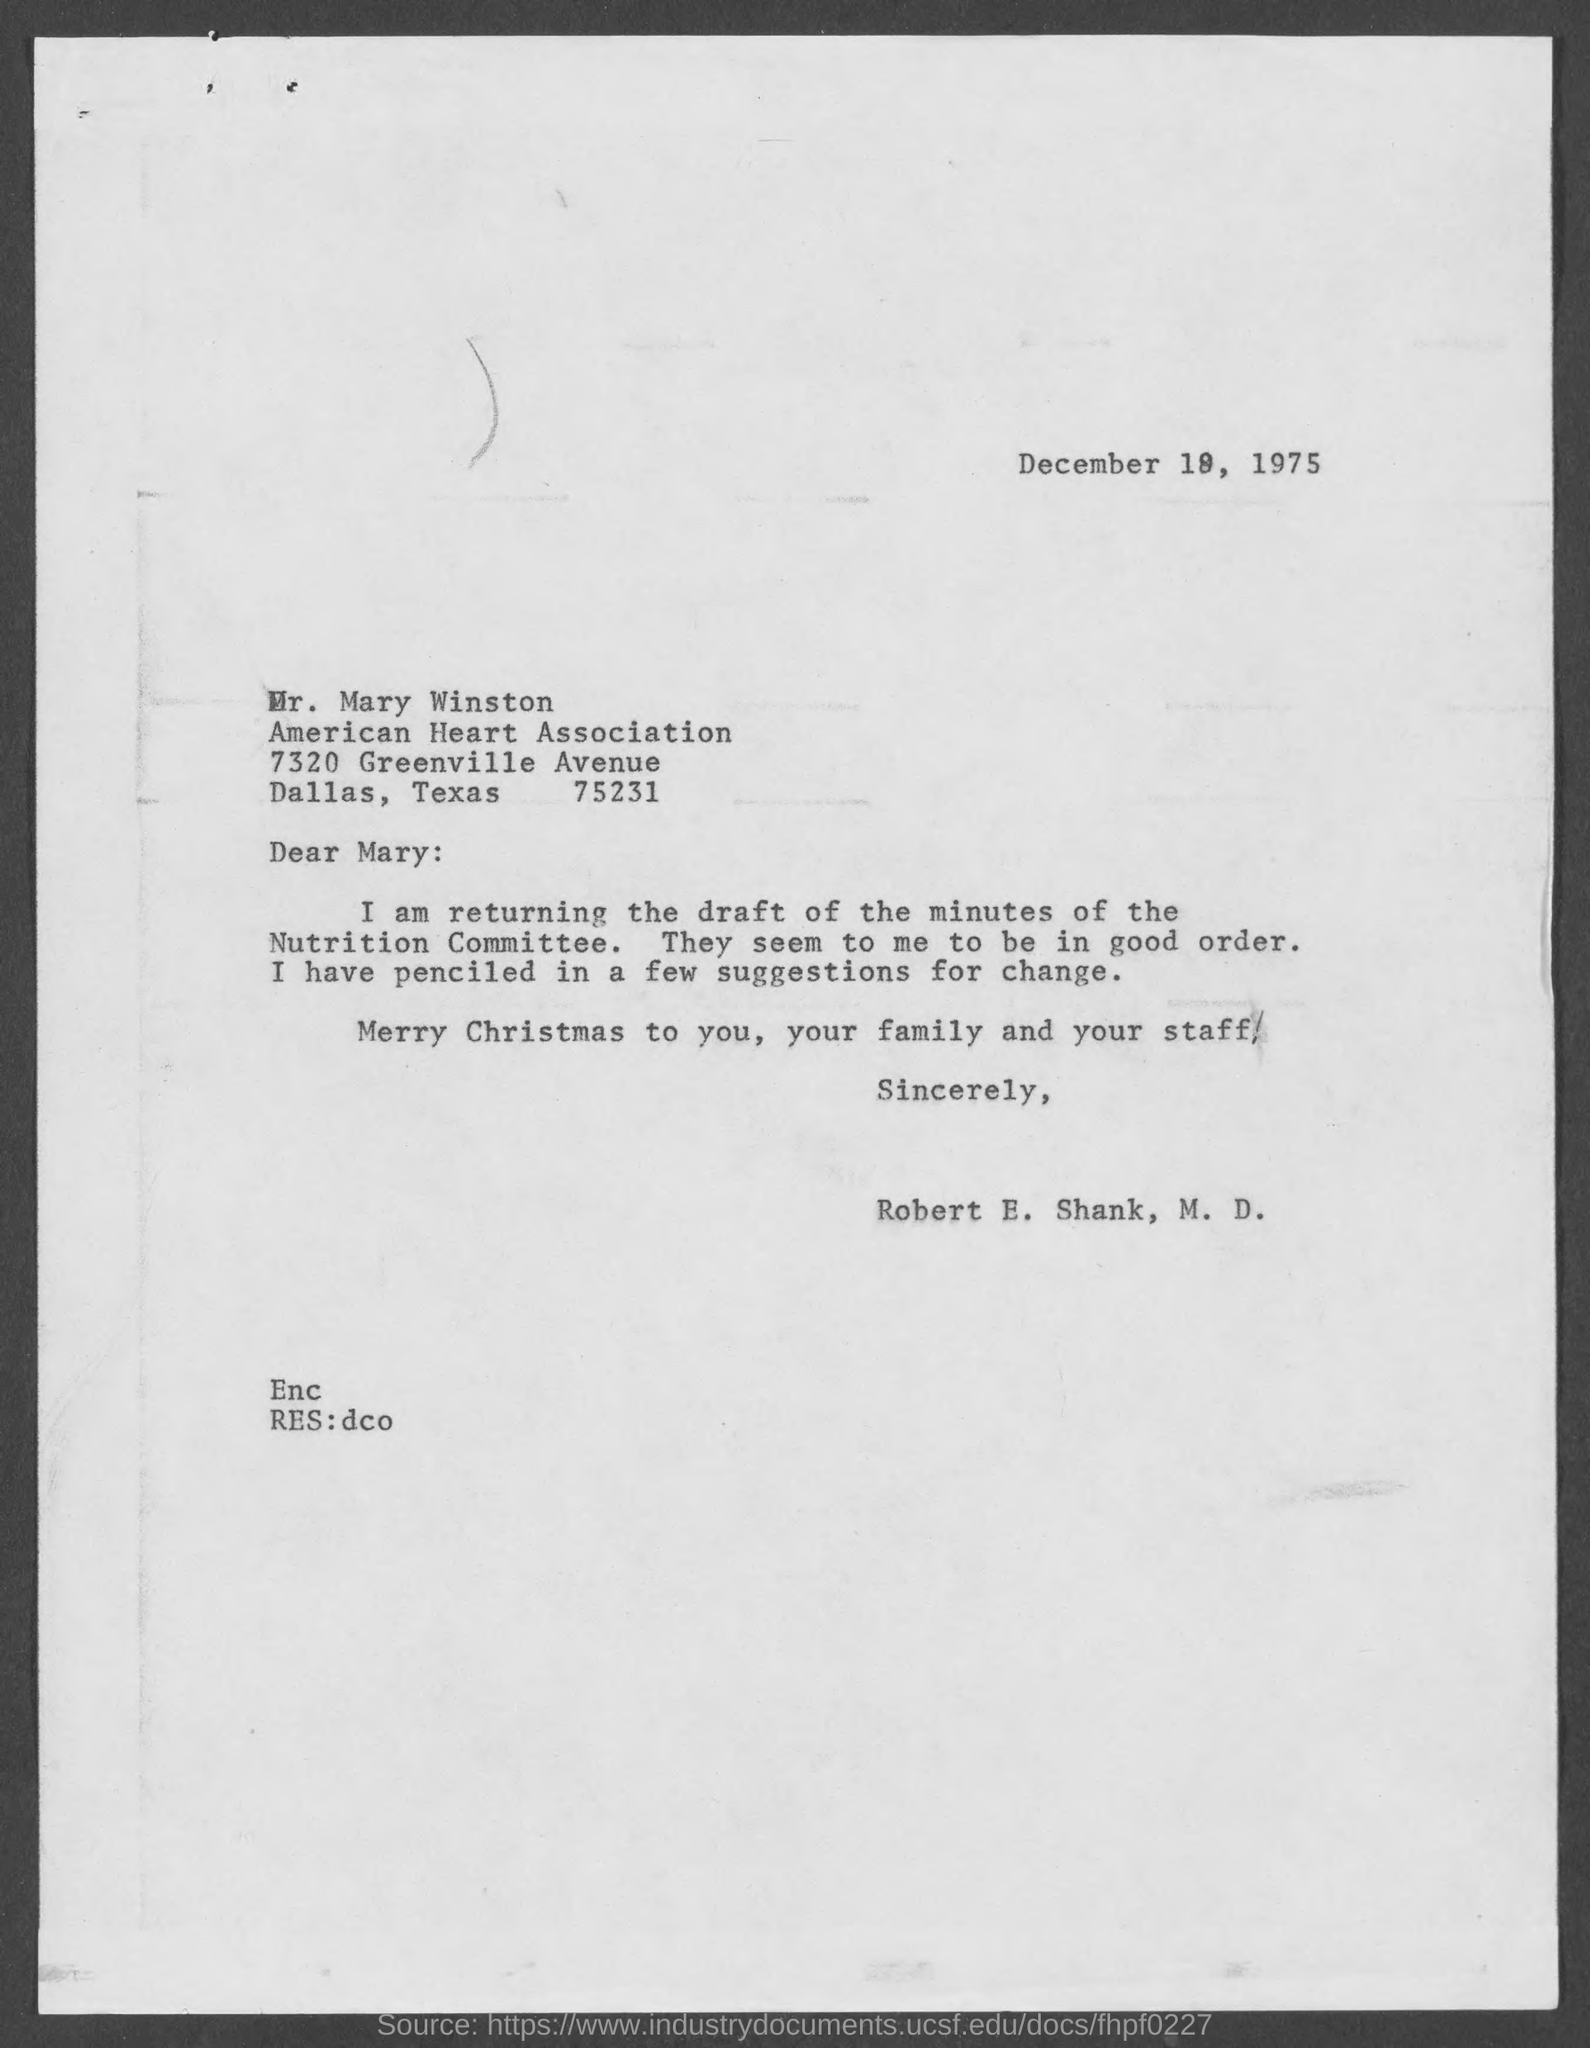What is the date mentioned ?
Keep it short and to the point. December 19, 1975. 